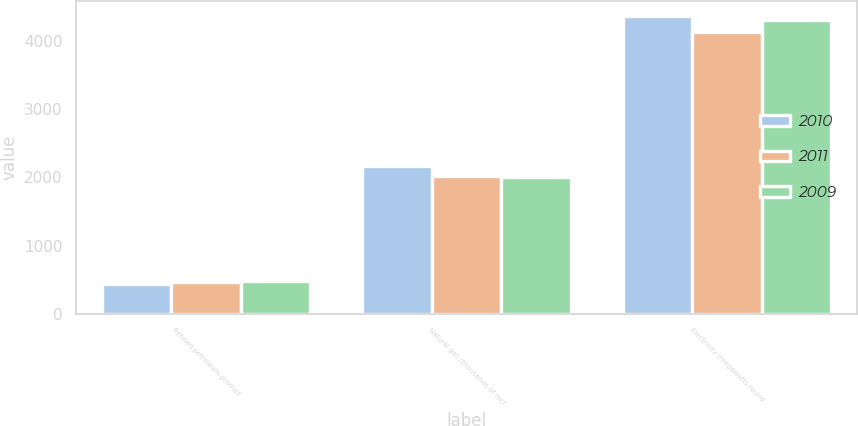<chart> <loc_0><loc_0><loc_500><loc_500><stacked_bar_chart><ecel><fcel>Refined petroleum product<fcel>Natural gas (thousands of mcf<fcel>Electricity (megawatts round<nl><fcel>2010<fcel>430<fcel>2167<fcel>4374<nl><fcel>2011<fcel>471<fcel>2016<fcel>4140<nl><fcel>2009<fcel>473<fcel>2010<fcel>4306<nl></chart> 